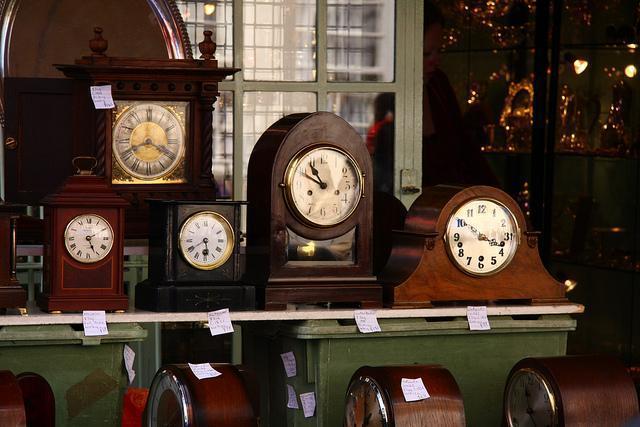How many clocks can you see?
Give a very brief answer. 7. 